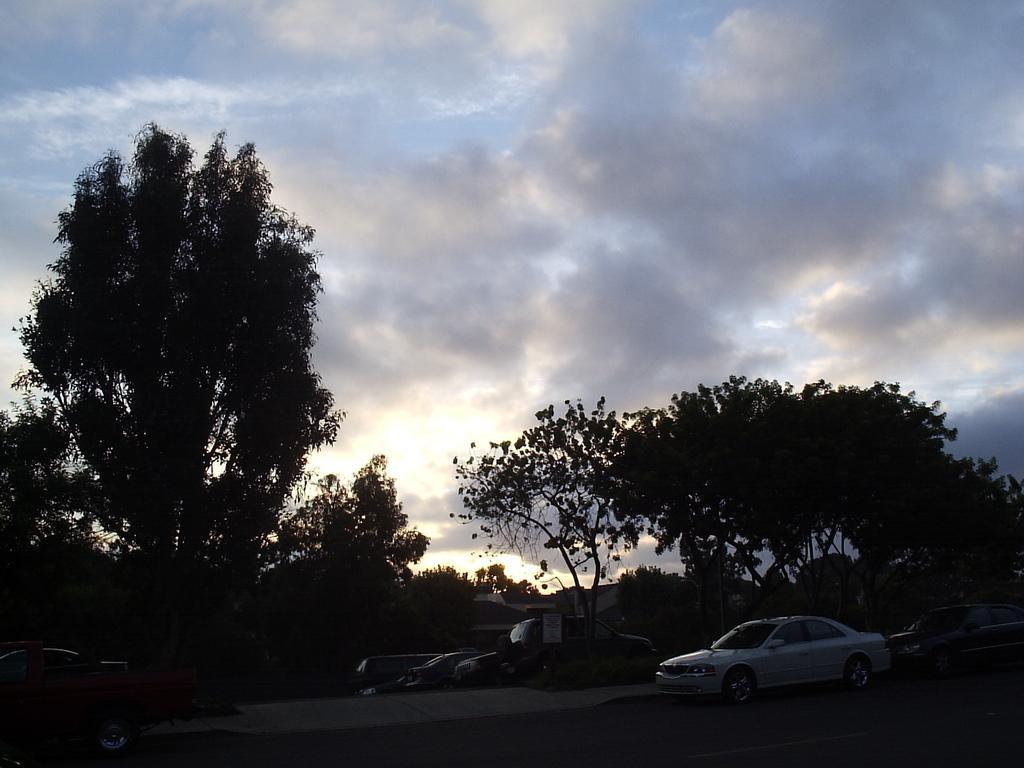Please provide a concise description of this image. In this image I can see the vehicles on the road. In the background, I can see the trees and clouds in the sky. 